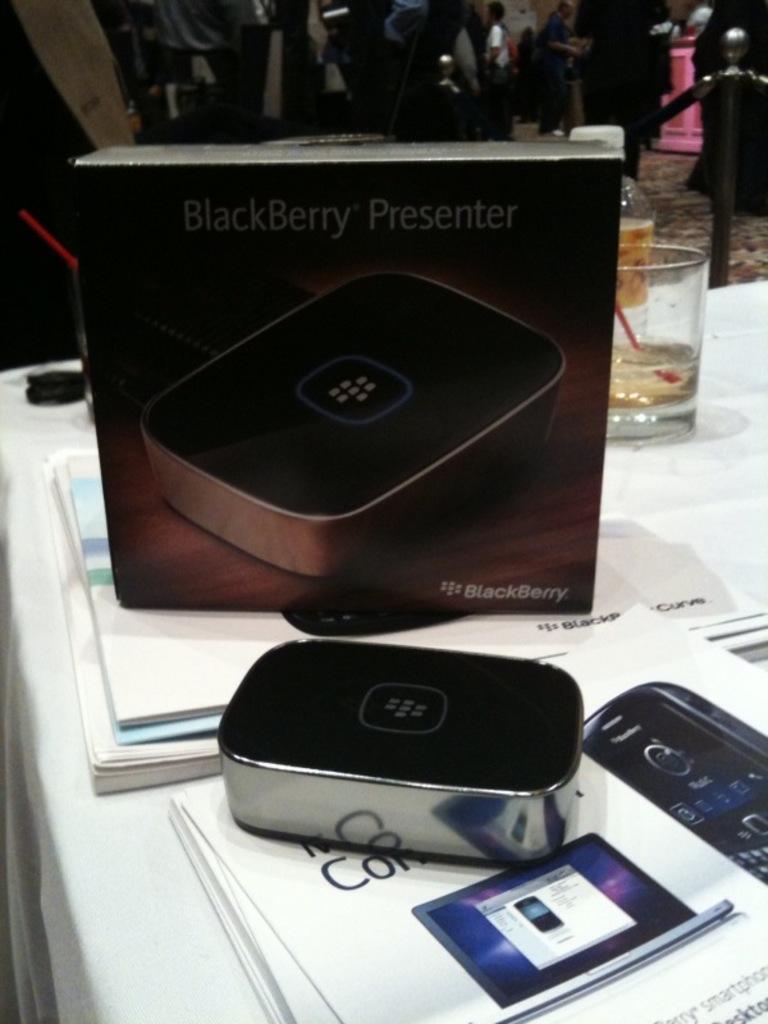What brand is the presenter?
Give a very brief answer. Blackberry. What is picture?
Your response must be concise. Blackberry presenter. 